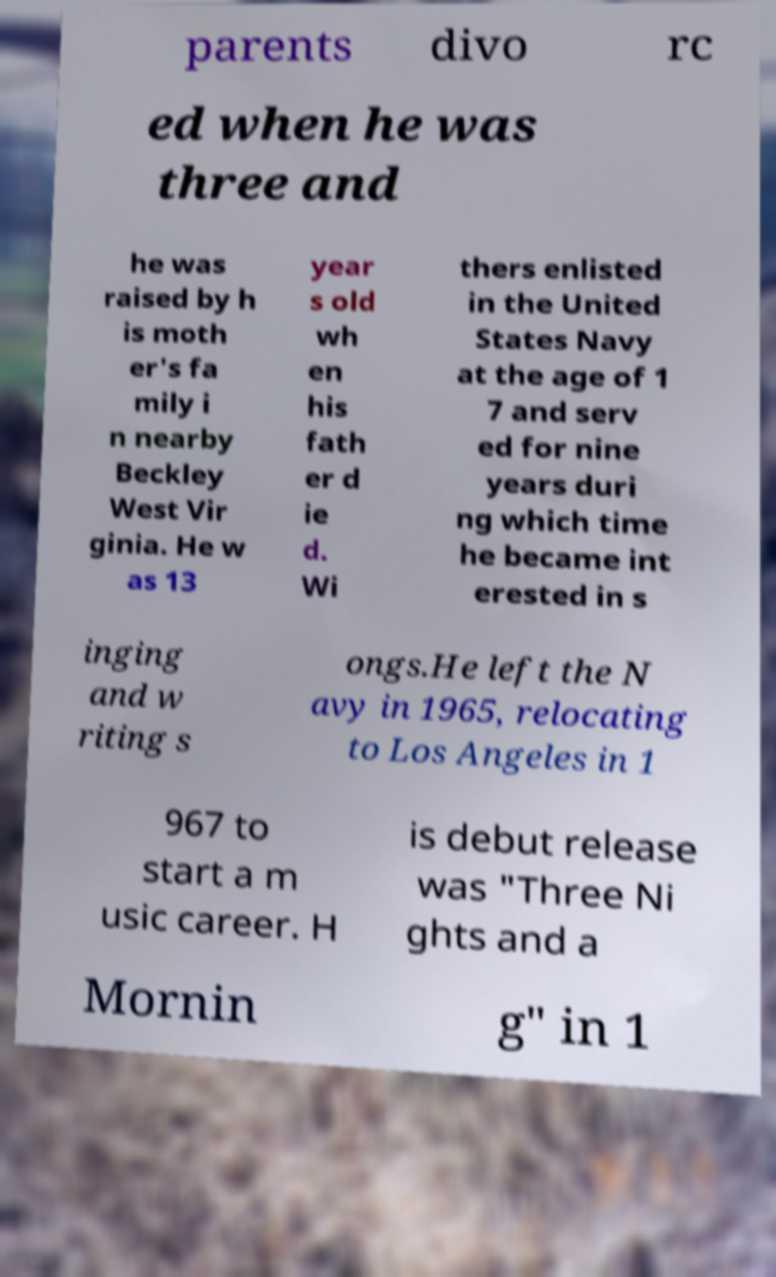Can you accurately transcribe the text from the provided image for me? parents divo rc ed when he was three and he was raised by h is moth er's fa mily i n nearby Beckley West Vir ginia. He w as 13 year s old wh en his fath er d ie d. Wi thers enlisted in the United States Navy at the age of 1 7 and serv ed for nine years duri ng which time he became int erested in s inging and w riting s ongs.He left the N avy in 1965, relocating to Los Angeles in 1 967 to start a m usic career. H is debut release was "Three Ni ghts and a Mornin g" in 1 